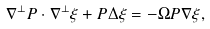Convert formula to latex. <formula><loc_0><loc_0><loc_500><loc_500>\nabla ^ { \perp } P \cdot \nabla ^ { \perp } \xi + P \Delta \xi = - \Omega P \nabla \xi ,</formula> 